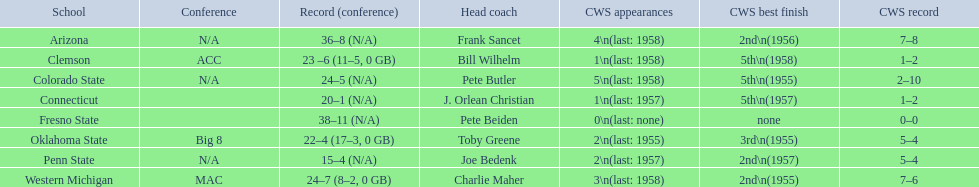Can you provide the names of every school? Arizona, Clemson, Colorado State, Connecticut, Fresno State, Oklahoma State, Penn State, Western Michigan. What are their respective records? 36–8 (N/A), 23 –6 (11–5, 0 GB), 24–5 (N/A), 20–1 (N/A), 38–11 (N/A), 22–4 (17–3, 0 GB), 15–4 (N/A), 24–7 (8–2, 0 GB). Which educational institution experienced the least amount of wins? Penn State. 